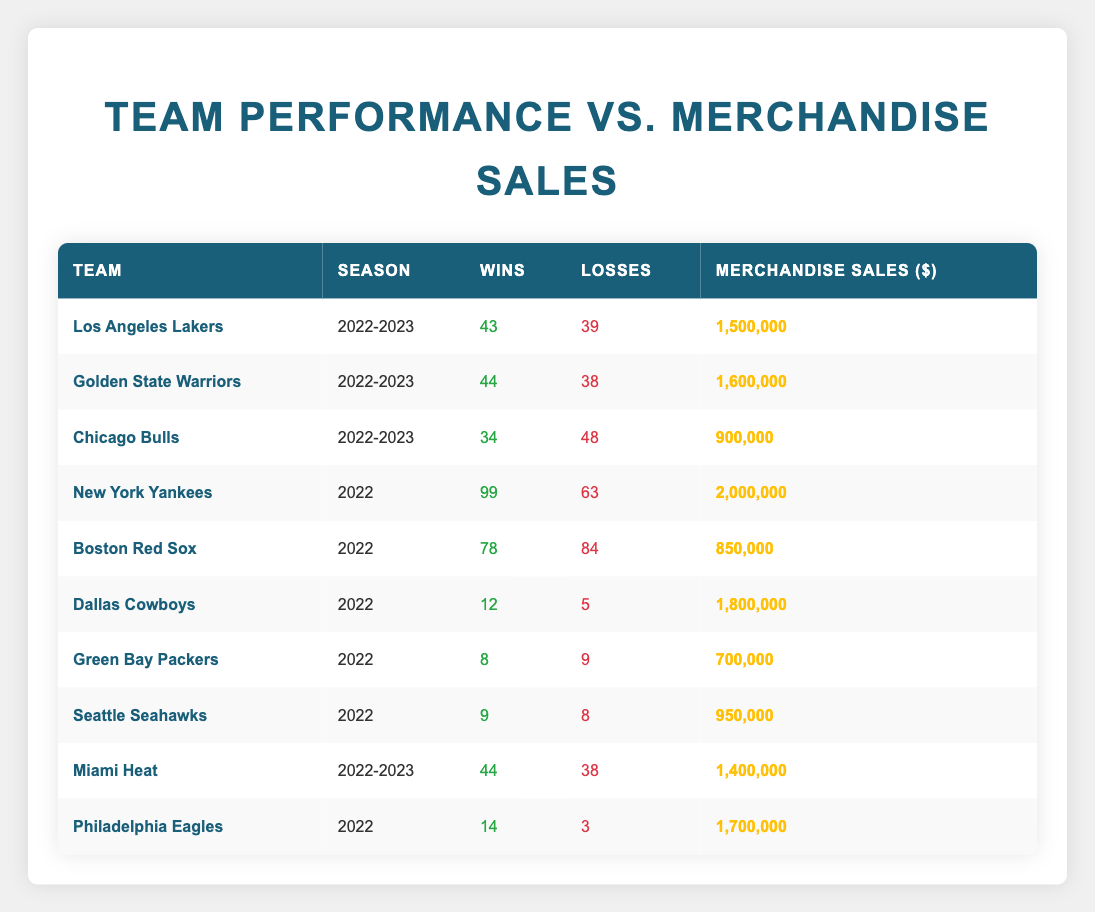What team had the highest merchandise sales? By inspecting the merchandise sales column, we see the New York Yankees had the highest sales at 2,000,000 dollars.
Answer: New York Yankees How many games did the Miami Heat win in the 2022-2023 season? The table directly shows that the Miami Heat had 44 wins in the 2022-2023 season.
Answer: 44 Which team had the lowest merchandise sales and what was the amount? Looking at the merchandise sales, the Chicago Bulls had the lowest with sales of 900,000 dollars.
Answer: Chicago Bulls, 900,000 What is the total number of wins for all teams listed in the table? Adding the wins from all teams, we have 43 + 44 + 34 + 99 + 78 + 12 + 8 + 9 + 44 + 14 = 392 total wins.
Answer: 392 Did the Philadelphia Eagles have more wins than the Dallas Cowboys? The Philadelphia Eagles had 14 wins, whereas the Dallas Cowboys had only 12 wins, thus yes, the Eagles had more wins.
Answer: Yes Which team had the most losses and how many were there? The team with the most losses is the Chicago Bulls with 48 losses.
Answer: Chicago Bulls, 48 What is the difference in merchandise sales between the Golden State Warriors and the Chicago Bulls? The sales for the Warriors is 1,600,000 and for the Bulls is 900,000. The difference is 1,600,000 - 900,000 = 700,000.
Answer: 700,000 Are the losses of the Green Bay Packers greater than the wins of the Los Angeles Lakers? The Green Bay Packers had 9 losses while the Los Angeles Lakers had 43 wins. Thus, the Packers' losses are not greater.
Answer: No Calculate the average number of wins for all teams in the table. There are 10 teams in total, summing their wins gives 392. To find the average, divide by 10: 392/10 = 39.2.
Answer: 39.2 